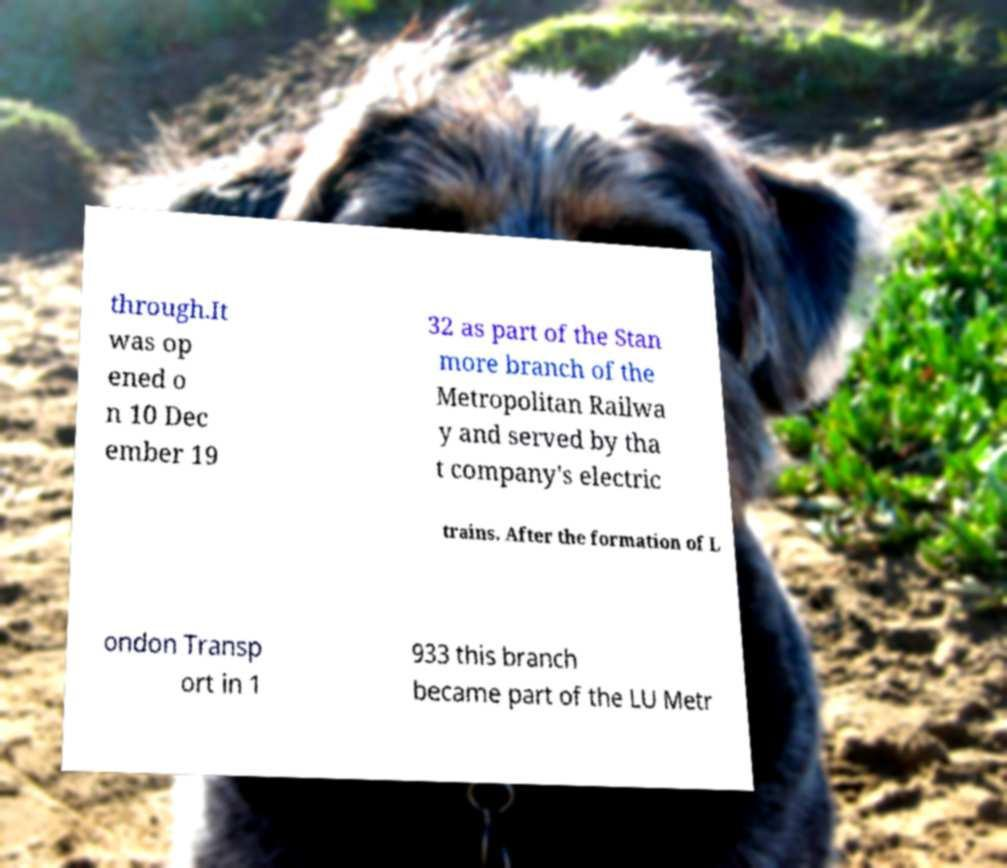Please read and relay the text visible in this image. What does it say? through.It was op ened o n 10 Dec ember 19 32 as part of the Stan more branch of the Metropolitan Railwa y and served by tha t company's electric trains. After the formation of L ondon Transp ort in 1 933 this branch became part of the LU Metr 